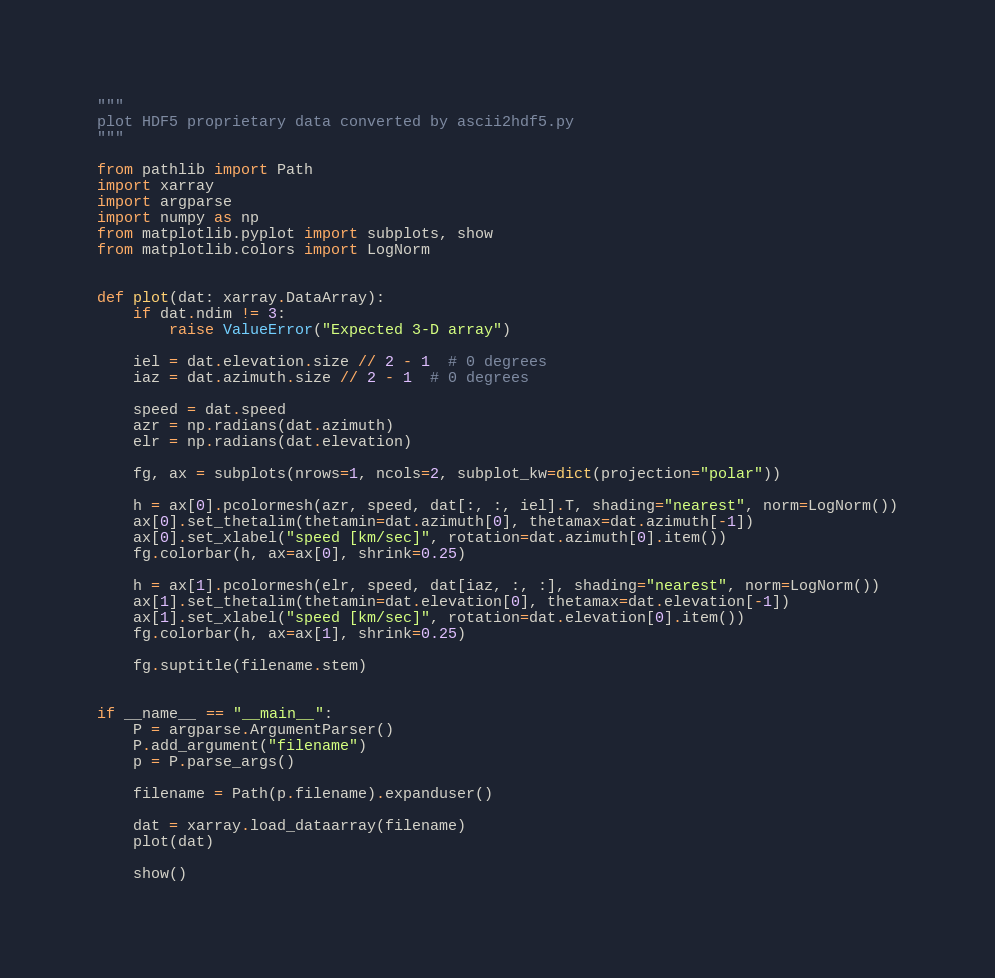Convert code to text. <code><loc_0><loc_0><loc_500><loc_500><_Python_>"""
plot HDF5 proprietary data converted by ascii2hdf5.py
"""

from pathlib import Path
import xarray
import argparse
import numpy as np
from matplotlib.pyplot import subplots, show
from matplotlib.colors import LogNorm


def plot(dat: xarray.DataArray):
    if dat.ndim != 3:
        raise ValueError("Expected 3-D array")

    iel = dat.elevation.size // 2 - 1  # 0 degrees
    iaz = dat.azimuth.size // 2 - 1  # 0 degrees

    speed = dat.speed
    azr = np.radians(dat.azimuth)
    elr = np.radians(dat.elevation)

    fg, ax = subplots(nrows=1, ncols=2, subplot_kw=dict(projection="polar"))

    h = ax[0].pcolormesh(azr, speed, dat[:, :, iel].T, shading="nearest", norm=LogNorm())
    ax[0].set_thetalim(thetamin=dat.azimuth[0], thetamax=dat.azimuth[-1])
    ax[0].set_xlabel("speed [km/sec]", rotation=dat.azimuth[0].item())
    fg.colorbar(h, ax=ax[0], shrink=0.25)

    h = ax[1].pcolormesh(elr, speed, dat[iaz, :, :], shading="nearest", norm=LogNorm())
    ax[1].set_thetalim(thetamin=dat.elevation[0], thetamax=dat.elevation[-1])
    ax[1].set_xlabel("speed [km/sec]", rotation=dat.elevation[0].item())
    fg.colorbar(h, ax=ax[1], shrink=0.25)

    fg.suptitle(filename.stem)


if __name__ == "__main__":
    P = argparse.ArgumentParser()
    P.add_argument("filename")
    p = P.parse_args()

    filename = Path(p.filename).expanduser()

    dat = xarray.load_dataarray(filename)
    plot(dat)

    show()
</code> 